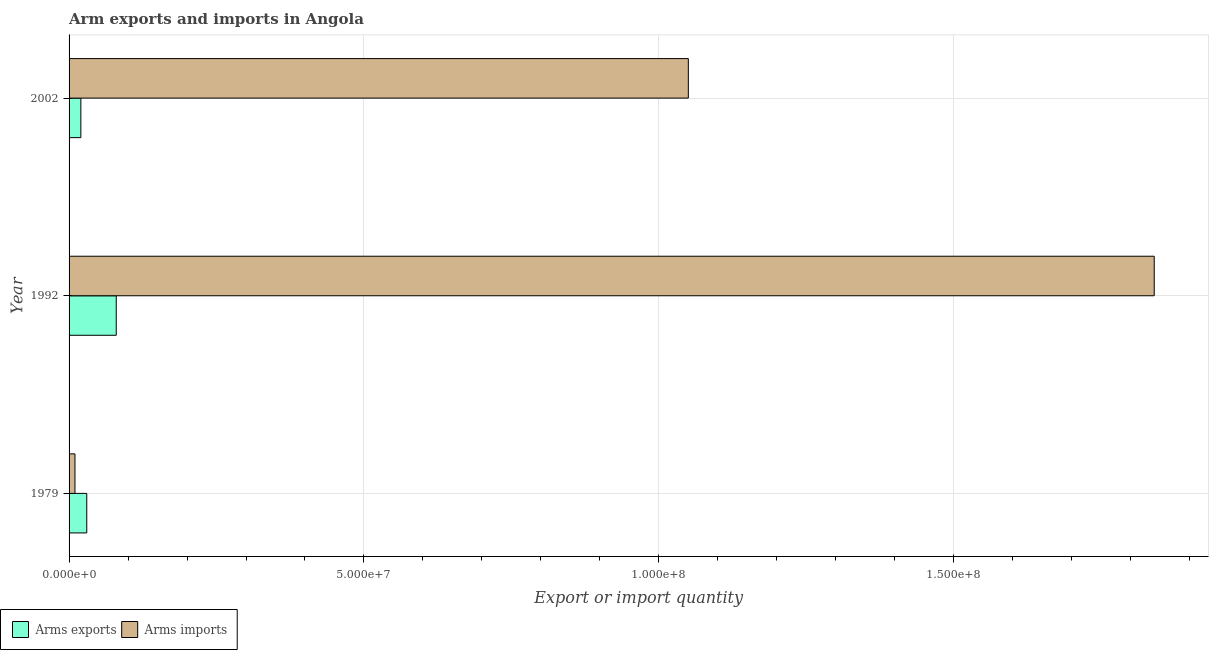How many groups of bars are there?
Provide a short and direct response. 3. What is the label of the 3rd group of bars from the top?
Offer a terse response. 1979. What is the arms exports in 1979?
Offer a terse response. 3.00e+06. Across all years, what is the maximum arms exports?
Your answer should be compact. 8.00e+06. Across all years, what is the minimum arms imports?
Ensure brevity in your answer.  1.00e+06. What is the total arms imports in the graph?
Offer a terse response. 2.90e+08. What is the difference between the arms imports in 1979 and that in 1992?
Your response must be concise. -1.83e+08. What is the difference between the arms exports in 1979 and the arms imports in 2002?
Your answer should be compact. -1.02e+08. What is the average arms imports per year?
Offer a terse response. 9.67e+07. In the year 1992, what is the difference between the arms exports and arms imports?
Offer a terse response. -1.76e+08. What is the ratio of the arms imports in 1979 to that in 2002?
Offer a very short reply. 0.01. Is the difference between the arms imports in 1979 and 1992 greater than the difference between the arms exports in 1979 and 1992?
Ensure brevity in your answer.  No. What is the difference between the highest and the second highest arms exports?
Offer a very short reply. 5.00e+06. What is the difference between the highest and the lowest arms exports?
Your response must be concise. 6.00e+06. Is the sum of the arms exports in 1979 and 2002 greater than the maximum arms imports across all years?
Your answer should be compact. No. What does the 2nd bar from the top in 1979 represents?
Offer a very short reply. Arms exports. What does the 1st bar from the bottom in 1992 represents?
Provide a short and direct response. Arms exports. Are all the bars in the graph horizontal?
Make the answer very short. Yes. How many years are there in the graph?
Provide a short and direct response. 3. Are the values on the major ticks of X-axis written in scientific E-notation?
Provide a succinct answer. Yes. Does the graph contain any zero values?
Your response must be concise. No. Does the graph contain grids?
Provide a succinct answer. Yes. Where does the legend appear in the graph?
Offer a terse response. Bottom left. What is the title of the graph?
Keep it short and to the point. Arm exports and imports in Angola. Does "Techinal cooperation" appear as one of the legend labels in the graph?
Ensure brevity in your answer.  No. What is the label or title of the X-axis?
Provide a succinct answer. Export or import quantity. What is the label or title of the Y-axis?
Keep it short and to the point. Year. What is the Export or import quantity of Arms exports in 1979?
Provide a short and direct response. 3.00e+06. What is the Export or import quantity in Arms imports in 1992?
Offer a terse response. 1.84e+08. What is the Export or import quantity in Arms imports in 2002?
Your response must be concise. 1.05e+08. Across all years, what is the maximum Export or import quantity in Arms exports?
Your answer should be very brief. 8.00e+06. Across all years, what is the maximum Export or import quantity in Arms imports?
Give a very brief answer. 1.84e+08. Across all years, what is the minimum Export or import quantity in Arms imports?
Your response must be concise. 1.00e+06. What is the total Export or import quantity in Arms exports in the graph?
Your answer should be compact. 1.30e+07. What is the total Export or import quantity in Arms imports in the graph?
Keep it short and to the point. 2.90e+08. What is the difference between the Export or import quantity of Arms exports in 1979 and that in 1992?
Offer a terse response. -5.00e+06. What is the difference between the Export or import quantity in Arms imports in 1979 and that in 1992?
Provide a short and direct response. -1.83e+08. What is the difference between the Export or import quantity of Arms exports in 1979 and that in 2002?
Your answer should be very brief. 1.00e+06. What is the difference between the Export or import quantity of Arms imports in 1979 and that in 2002?
Provide a short and direct response. -1.04e+08. What is the difference between the Export or import quantity of Arms exports in 1992 and that in 2002?
Your response must be concise. 6.00e+06. What is the difference between the Export or import quantity in Arms imports in 1992 and that in 2002?
Give a very brief answer. 7.90e+07. What is the difference between the Export or import quantity of Arms exports in 1979 and the Export or import quantity of Arms imports in 1992?
Ensure brevity in your answer.  -1.81e+08. What is the difference between the Export or import quantity of Arms exports in 1979 and the Export or import quantity of Arms imports in 2002?
Make the answer very short. -1.02e+08. What is the difference between the Export or import quantity in Arms exports in 1992 and the Export or import quantity in Arms imports in 2002?
Provide a short and direct response. -9.70e+07. What is the average Export or import quantity in Arms exports per year?
Give a very brief answer. 4.33e+06. What is the average Export or import quantity of Arms imports per year?
Offer a very short reply. 9.67e+07. In the year 1979, what is the difference between the Export or import quantity in Arms exports and Export or import quantity in Arms imports?
Your answer should be compact. 2.00e+06. In the year 1992, what is the difference between the Export or import quantity of Arms exports and Export or import quantity of Arms imports?
Keep it short and to the point. -1.76e+08. In the year 2002, what is the difference between the Export or import quantity of Arms exports and Export or import quantity of Arms imports?
Provide a short and direct response. -1.03e+08. What is the ratio of the Export or import quantity in Arms exports in 1979 to that in 1992?
Your response must be concise. 0.38. What is the ratio of the Export or import quantity in Arms imports in 1979 to that in 1992?
Keep it short and to the point. 0.01. What is the ratio of the Export or import quantity in Arms exports in 1979 to that in 2002?
Make the answer very short. 1.5. What is the ratio of the Export or import quantity in Arms imports in 1979 to that in 2002?
Provide a short and direct response. 0.01. What is the ratio of the Export or import quantity in Arms exports in 1992 to that in 2002?
Provide a short and direct response. 4. What is the ratio of the Export or import quantity in Arms imports in 1992 to that in 2002?
Offer a very short reply. 1.75. What is the difference between the highest and the second highest Export or import quantity in Arms imports?
Offer a terse response. 7.90e+07. What is the difference between the highest and the lowest Export or import quantity of Arms imports?
Give a very brief answer. 1.83e+08. 